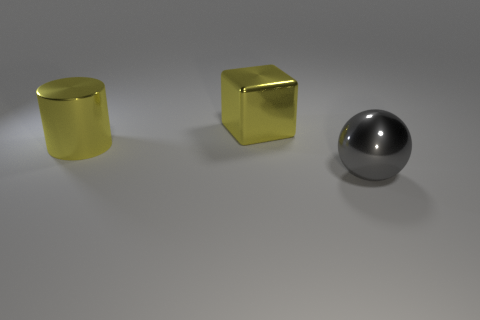Add 3 yellow shiny cylinders. How many objects exist? 6 Subtract all spheres. How many objects are left? 2 Subtract all tiny purple spheres. Subtract all large things. How many objects are left? 0 Add 2 metal things. How many metal things are left? 5 Add 3 big rubber cylinders. How many big rubber cylinders exist? 3 Subtract 1 yellow cubes. How many objects are left? 2 